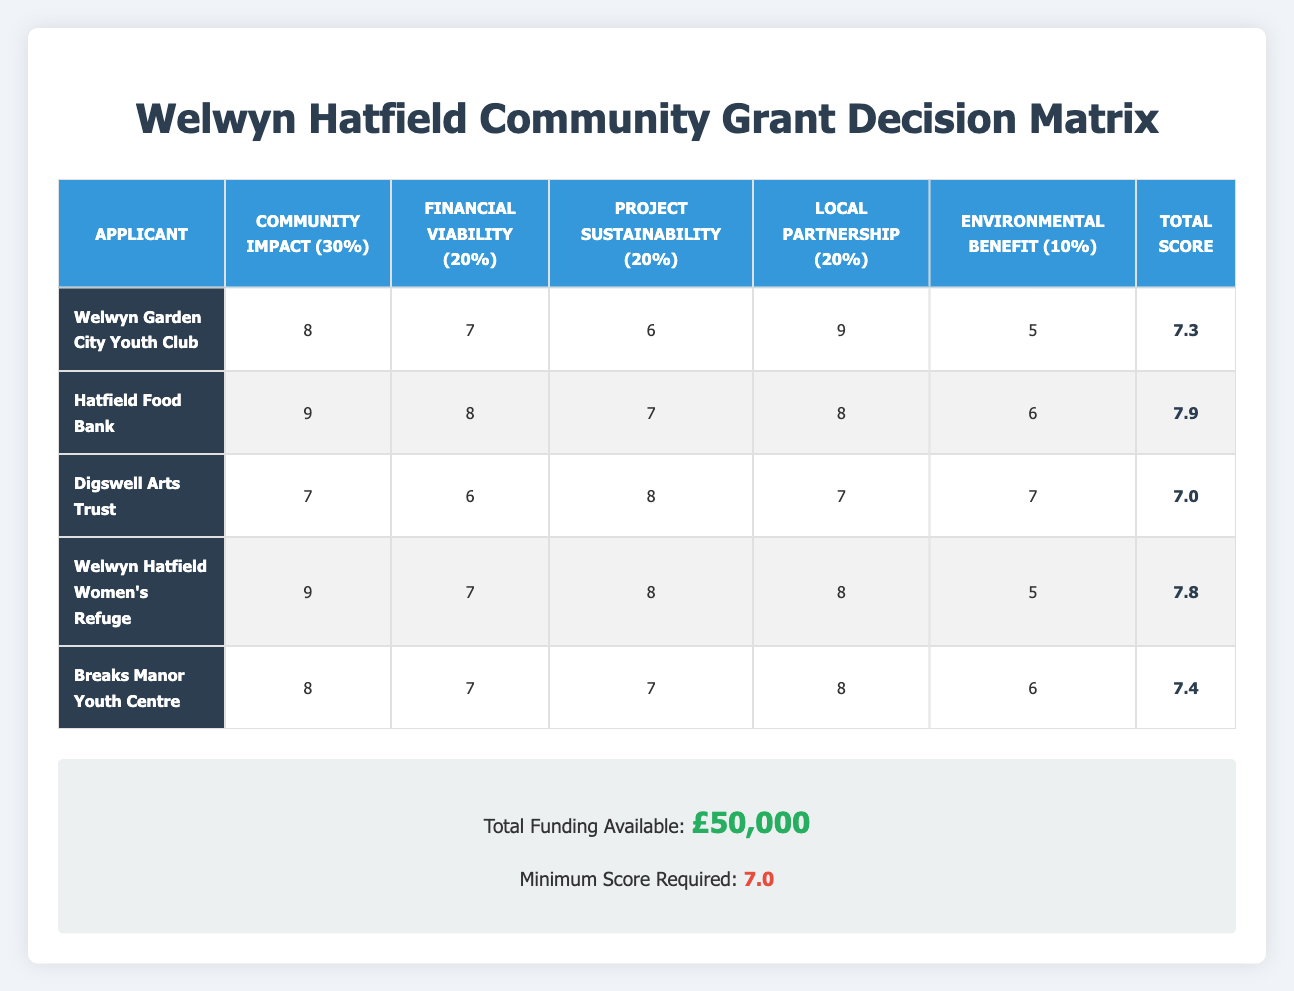What is the total score for Hatfield Food Bank? The total score is listed in the final column for each applicant. For Hatfield Food Bank, the total score is 7.9.
Answer: 7.9 Which project has the highest Community Impact score? By comparing the Community Impact scores across all applicants, Hatfield Food Bank has the highest score of 9.
Answer: Hatfield Food Bank Is the minimum score required met by Digswell Arts Trust? The minimum score required is 7.0. Digswell Arts Trust has a total score of 7.0, which means it meets the minimum requirement.
Answer: Yes How many applicants scored below the average score of 7.4? The average score is calculated by summing all total scores (7.3 + 7.9 + 7.0 + 7.8 + 7.4 = 37.4) and dividing by the number of applicants (5). Thus, the average score is 37.4 / 5 = 7.48. The applicants scoring below this average are Welwyn Garden City Youth Club (7.3) and Digswell Arts Trust (7.0), totaling 2 applicants.
Answer: 2 What is the Community Impact score for Welwyn Hatfield Women's Refuge? The score for Community Impact for Welwyn Hatfield Women's Refuge is directly referenced in the table and is listed as 9.
Answer: 9 Which applicant has the best financial viability score? Upon reviewing the Financial Viability scores, Hatfield Food Bank scores the highest with a score of 8.
Answer: Hatfield Food Bank Is there any applicant who scored exactly 7.0? The score table shows that Digswell Arts Trust has a total score of 7.0, which exactly meets this requirement.
Answer: Yes Calculate the score difference between the highest and lowest scoring applicant. The highest total score is from Hatfield Food Bank at 7.9, while the lowest is Digswell Arts Trust at 7.0. The difference is calculated as follows: 7.9 - 7.0 = 0.9.
Answer: 0.9 How many criteria scored 8 or above for Breaks Manor Youth Centre? Examining the criteria scores for Breaks Manor Youth Centre, we see it scored 8 in both Local Partnership and Community Impact. Therefore, there are 2 criteria scored 8 or above.
Answer: 2 